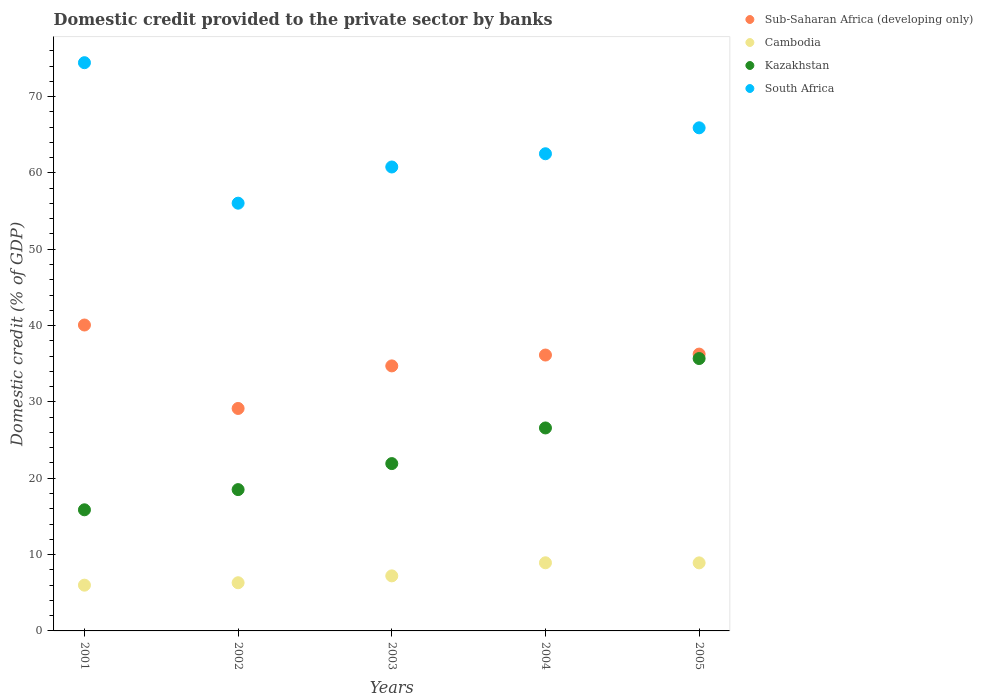Is the number of dotlines equal to the number of legend labels?
Keep it short and to the point. Yes. What is the domestic credit provided to the private sector by banks in Kazakhstan in 2004?
Make the answer very short. 26.59. Across all years, what is the maximum domestic credit provided to the private sector by banks in Kazakhstan?
Provide a succinct answer. 35.68. Across all years, what is the minimum domestic credit provided to the private sector by banks in Kazakhstan?
Offer a very short reply. 15.87. In which year was the domestic credit provided to the private sector by banks in South Africa maximum?
Provide a succinct answer. 2001. What is the total domestic credit provided to the private sector by banks in Cambodia in the graph?
Provide a succinct answer. 37.36. What is the difference between the domestic credit provided to the private sector by banks in Sub-Saharan Africa (developing only) in 2003 and that in 2004?
Keep it short and to the point. -1.42. What is the difference between the domestic credit provided to the private sector by banks in Kazakhstan in 2002 and the domestic credit provided to the private sector by banks in Cambodia in 2001?
Offer a terse response. 12.52. What is the average domestic credit provided to the private sector by banks in South Africa per year?
Give a very brief answer. 63.93. In the year 2005, what is the difference between the domestic credit provided to the private sector by banks in Kazakhstan and domestic credit provided to the private sector by banks in Sub-Saharan Africa (developing only)?
Offer a terse response. -0.58. What is the ratio of the domestic credit provided to the private sector by banks in South Africa in 2003 to that in 2005?
Your response must be concise. 0.92. Is the difference between the domestic credit provided to the private sector by banks in Kazakhstan in 2003 and 2004 greater than the difference between the domestic credit provided to the private sector by banks in Sub-Saharan Africa (developing only) in 2003 and 2004?
Offer a terse response. No. What is the difference between the highest and the second highest domestic credit provided to the private sector by banks in South Africa?
Offer a very short reply. 8.53. What is the difference between the highest and the lowest domestic credit provided to the private sector by banks in Sub-Saharan Africa (developing only)?
Give a very brief answer. 10.93. In how many years, is the domestic credit provided to the private sector by banks in Kazakhstan greater than the average domestic credit provided to the private sector by banks in Kazakhstan taken over all years?
Offer a terse response. 2. Is it the case that in every year, the sum of the domestic credit provided to the private sector by banks in South Africa and domestic credit provided to the private sector by banks in Sub-Saharan Africa (developing only)  is greater than the sum of domestic credit provided to the private sector by banks in Kazakhstan and domestic credit provided to the private sector by banks in Cambodia?
Your answer should be very brief. Yes. Is it the case that in every year, the sum of the domestic credit provided to the private sector by banks in South Africa and domestic credit provided to the private sector by banks in Kazakhstan  is greater than the domestic credit provided to the private sector by banks in Sub-Saharan Africa (developing only)?
Your answer should be very brief. Yes. Is the domestic credit provided to the private sector by banks in Kazakhstan strictly greater than the domestic credit provided to the private sector by banks in Cambodia over the years?
Make the answer very short. Yes. How many years are there in the graph?
Make the answer very short. 5. What is the difference between two consecutive major ticks on the Y-axis?
Your response must be concise. 10. Does the graph contain any zero values?
Ensure brevity in your answer.  No. Does the graph contain grids?
Provide a short and direct response. No. Where does the legend appear in the graph?
Give a very brief answer. Top right. How many legend labels are there?
Give a very brief answer. 4. How are the legend labels stacked?
Provide a short and direct response. Vertical. What is the title of the graph?
Your answer should be very brief. Domestic credit provided to the private sector by banks. What is the label or title of the X-axis?
Ensure brevity in your answer.  Years. What is the label or title of the Y-axis?
Give a very brief answer. Domestic credit (% of GDP). What is the Domestic credit (% of GDP) in Sub-Saharan Africa (developing only) in 2001?
Your response must be concise. 40.07. What is the Domestic credit (% of GDP) of Cambodia in 2001?
Provide a succinct answer. 5.99. What is the Domestic credit (% of GDP) of Kazakhstan in 2001?
Provide a short and direct response. 15.87. What is the Domestic credit (% of GDP) of South Africa in 2001?
Keep it short and to the point. 74.43. What is the Domestic credit (% of GDP) of Sub-Saharan Africa (developing only) in 2002?
Keep it short and to the point. 29.14. What is the Domestic credit (% of GDP) in Cambodia in 2002?
Keep it short and to the point. 6.31. What is the Domestic credit (% of GDP) in Kazakhstan in 2002?
Your answer should be very brief. 18.51. What is the Domestic credit (% of GDP) in South Africa in 2002?
Ensure brevity in your answer.  56.03. What is the Domestic credit (% of GDP) in Sub-Saharan Africa (developing only) in 2003?
Ensure brevity in your answer.  34.72. What is the Domestic credit (% of GDP) in Cambodia in 2003?
Ensure brevity in your answer.  7.21. What is the Domestic credit (% of GDP) in Kazakhstan in 2003?
Keep it short and to the point. 21.92. What is the Domestic credit (% of GDP) of South Africa in 2003?
Ensure brevity in your answer.  60.77. What is the Domestic credit (% of GDP) in Sub-Saharan Africa (developing only) in 2004?
Your answer should be very brief. 36.14. What is the Domestic credit (% of GDP) in Cambodia in 2004?
Give a very brief answer. 8.92. What is the Domestic credit (% of GDP) of Kazakhstan in 2004?
Your answer should be compact. 26.59. What is the Domestic credit (% of GDP) in South Africa in 2004?
Offer a terse response. 62.5. What is the Domestic credit (% of GDP) of Sub-Saharan Africa (developing only) in 2005?
Make the answer very short. 36.26. What is the Domestic credit (% of GDP) in Cambodia in 2005?
Provide a short and direct response. 8.92. What is the Domestic credit (% of GDP) of Kazakhstan in 2005?
Your answer should be compact. 35.68. What is the Domestic credit (% of GDP) of South Africa in 2005?
Your response must be concise. 65.9. Across all years, what is the maximum Domestic credit (% of GDP) of Sub-Saharan Africa (developing only)?
Give a very brief answer. 40.07. Across all years, what is the maximum Domestic credit (% of GDP) in Cambodia?
Your answer should be compact. 8.92. Across all years, what is the maximum Domestic credit (% of GDP) in Kazakhstan?
Keep it short and to the point. 35.68. Across all years, what is the maximum Domestic credit (% of GDP) in South Africa?
Your answer should be compact. 74.43. Across all years, what is the minimum Domestic credit (% of GDP) of Sub-Saharan Africa (developing only)?
Make the answer very short. 29.14. Across all years, what is the minimum Domestic credit (% of GDP) of Cambodia?
Your answer should be very brief. 5.99. Across all years, what is the minimum Domestic credit (% of GDP) in Kazakhstan?
Offer a very short reply. 15.87. Across all years, what is the minimum Domestic credit (% of GDP) in South Africa?
Your answer should be compact. 56.03. What is the total Domestic credit (% of GDP) of Sub-Saharan Africa (developing only) in the graph?
Keep it short and to the point. 176.33. What is the total Domestic credit (% of GDP) in Cambodia in the graph?
Provide a succinct answer. 37.36. What is the total Domestic credit (% of GDP) in Kazakhstan in the graph?
Offer a terse response. 118.56. What is the total Domestic credit (% of GDP) in South Africa in the graph?
Make the answer very short. 319.64. What is the difference between the Domestic credit (% of GDP) in Sub-Saharan Africa (developing only) in 2001 and that in 2002?
Your answer should be very brief. 10.93. What is the difference between the Domestic credit (% of GDP) in Cambodia in 2001 and that in 2002?
Offer a terse response. -0.32. What is the difference between the Domestic credit (% of GDP) of Kazakhstan in 2001 and that in 2002?
Provide a short and direct response. -2.65. What is the difference between the Domestic credit (% of GDP) of South Africa in 2001 and that in 2002?
Offer a terse response. 18.4. What is the difference between the Domestic credit (% of GDP) in Sub-Saharan Africa (developing only) in 2001 and that in 2003?
Your answer should be very brief. 5.36. What is the difference between the Domestic credit (% of GDP) in Cambodia in 2001 and that in 2003?
Your answer should be compact. -1.22. What is the difference between the Domestic credit (% of GDP) in Kazakhstan in 2001 and that in 2003?
Provide a succinct answer. -6.05. What is the difference between the Domestic credit (% of GDP) in South Africa in 2001 and that in 2003?
Give a very brief answer. 13.66. What is the difference between the Domestic credit (% of GDP) in Sub-Saharan Africa (developing only) in 2001 and that in 2004?
Provide a succinct answer. 3.93. What is the difference between the Domestic credit (% of GDP) of Cambodia in 2001 and that in 2004?
Offer a terse response. -2.93. What is the difference between the Domestic credit (% of GDP) in Kazakhstan in 2001 and that in 2004?
Offer a very short reply. -10.72. What is the difference between the Domestic credit (% of GDP) of South Africa in 2001 and that in 2004?
Your response must be concise. 11.93. What is the difference between the Domestic credit (% of GDP) in Sub-Saharan Africa (developing only) in 2001 and that in 2005?
Keep it short and to the point. 3.81. What is the difference between the Domestic credit (% of GDP) in Cambodia in 2001 and that in 2005?
Provide a succinct answer. -2.92. What is the difference between the Domestic credit (% of GDP) in Kazakhstan in 2001 and that in 2005?
Your response must be concise. -19.81. What is the difference between the Domestic credit (% of GDP) of South Africa in 2001 and that in 2005?
Keep it short and to the point. 8.53. What is the difference between the Domestic credit (% of GDP) in Sub-Saharan Africa (developing only) in 2002 and that in 2003?
Make the answer very short. -5.57. What is the difference between the Domestic credit (% of GDP) in Cambodia in 2002 and that in 2003?
Your answer should be compact. -0.9. What is the difference between the Domestic credit (% of GDP) of Kazakhstan in 2002 and that in 2003?
Your response must be concise. -3.41. What is the difference between the Domestic credit (% of GDP) of South Africa in 2002 and that in 2003?
Provide a short and direct response. -4.74. What is the difference between the Domestic credit (% of GDP) of Sub-Saharan Africa (developing only) in 2002 and that in 2004?
Keep it short and to the point. -7. What is the difference between the Domestic credit (% of GDP) of Cambodia in 2002 and that in 2004?
Provide a short and direct response. -2.61. What is the difference between the Domestic credit (% of GDP) of Kazakhstan in 2002 and that in 2004?
Offer a terse response. -8.08. What is the difference between the Domestic credit (% of GDP) of South Africa in 2002 and that in 2004?
Give a very brief answer. -6.47. What is the difference between the Domestic credit (% of GDP) in Sub-Saharan Africa (developing only) in 2002 and that in 2005?
Offer a terse response. -7.12. What is the difference between the Domestic credit (% of GDP) of Cambodia in 2002 and that in 2005?
Provide a short and direct response. -2.6. What is the difference between the Domestic credit (% of GDP) in Kazakhstan in 2002 and that in 2005?
Your answer should be very brief. -17.17. What is the difference between the Domestic credit (% of GDP) of South Africa in 2002 and that in 2005?
Offer a very short reply. -9.87. What is the difference between the Domestic credit (% of GDP) in Sub-Saharan Africa (developing only) in 2003 and that in 2004?
Your answer should be compact. -1.42. What is the difference between the Domestic credit (% of GDP) in Cambodia in 2003 and that in 2004?
Make the answer very short. -1.71. What is the difference between the Domestic credit (% of GDP) of Kazakhstan in 2003 and that in 2004?
Offer a very short reply. -4.67. What is the difference between the Domestic credit (% of GDP) in South Africa in 2003 and that in 2004?
Offer a terse response. -1.73. What is the difference between the Domestic credit (% of GDP) of Sub-Saharan Africa (developing only) in 2003 and that in 2005?
Keep it short and to the point. -1.55. What is the difference between the Domestic credit (% of GDP) of Cambodia in 2003 and that in 2005?
Provide a succinct answer. -1.7. What is the difference between the Domestic credit (% of GDP) in Kazakhstan in 2003 and that in 2005?
Offer a very short reply. -13.76. What is the difference between the Domestic credit (% of GDP) of South Africa in 2003 and that in 2005?
Make the answer very short. -5.13. What is the difference between the Domestic credit (% of GDP) in Sub-Saharan Africa (developing only) in 2004 and that in 2005?
Your answer should be very brief. -0.12. What is the difference between the Domestic credit (% of GDP) in Cambodia in 2004 and that in 2005?
Provide a short and direct response. 0.01. What is the difference between the Domestic credit (% of GDP) in Kazakhstan in 2004 and that in 2005?
Provide a succinct answer. -9.09. What is the difference between the Domestic credit (% of GDP) in South Africa in 2004 and that in 2005?
Provide a succinct answer. -3.4. What is the difference between the Domestic credit (% of GDP) of Sub-Saharan Africa (developing only) in 2001 and the Domestic credit (% of GDP) of Cambodia in 2002?
Provide a succinct answer. 33.76. What is the difference between the Domestic credit (% of GDP) of Sub-Saharan Africa (developing only) in 2001 and the Domestic credit (% of GDP) of Kazakhstan in 2002?
Offer a terse response. 21.56. What is the difference between the Domestic credit (% of GDP) of Sub-Saharan Africa (developing only) in 2001 and the Domestic credit (% of GDP) of South Africa in 2002?
Provide a short and direct response. -15.96. What is the difference between the Domestic credit (% of GDP) of Cambodia in 2001 and the Domestic credit (% of GDP) of Kazakhstan in 2002?
Provide a succinct answer. -12.52. What is the difference between the Domestic credit (% of GDP) in Cambodia in 2001 and the Domestic credit (% of GDP) in South Africa in 2002?
Give a very brief answer. -50.04. What is the difference between the Domestic credit (% of GDP) in Kazakhstan in 2001 and the Domestic credit (% of GDP) in South Africa in 2002?
Your answer should be very brief. -40.16. What is the difference between the Domestic credit (% of GDP) in Sub-Saharan Africa (developing only) in 2001 and the Domestic credit (% of GDP) in Cambodia in 2003?
Offer a terse response. 32.86. What is the difference between the Domestic credit (% of GDP) of Sub-Saharan Africa (developing only) in 2001 and the Domestic credit (% of GDP) of Kazakhstan in 2003?
Your response must be concise. 18.15. What is the difference between the Domestic credit (% of GDP) of Sub-Saharan Africa (developing only) in 2001 and the Domestic credit (% of GDP) of South Africa in 2003?
Make the answer very short. -20.7. What is the difference between the Domestic credit (% of GDP) in Cambodia in 2001 and the Domestic credit (% of GDP) in Kazakhstan in 2003?
Provide a short and direct response. -15.92. What is the difference between the Domestic credit (% of GDP) in Cambodia in 2001 and the Domestic credit (% of GDP) in South Africa in 2003?
Offer a terse response. -54.78. What is the difference between the Domestic credit (% of GDP) of Kazakhstan in 2001 and the Domestic credit (% of GDP) of South Africa in 2003?
Provide a succinct answer. -44.91. What is the difference between the Domestic credit (% of GDP) in Sub-Saharan Africa (developing only) in 2001 and the Domestic credit (% of GDP) in Cambodia in 2004?
Your response must be concise. 31.15. What is the difference between the Domestic credit (% of GDP) in Sub-Saharan Africa (developing only) in 2001 and the Domestic credit (% of GDP) in Kazakhstan in 2004?
Keep it short and to the point. 13.48. What is the difference between the Domestic credit (% of GDP) in Sub-Saharan Africa (developing only) in 2001 and the Domestic credit (% of GDP) in South Africa in 2004?
Your response must be concise. -22.43. What is the difference between the Domestic credit (% of GDP) in Cambodia in 2001 and the Domestic credit (% of GDP) in Kazakhstan in 2004?
Ensure brevity in your answer.  -20.59. What is the difference between the Domestic credit (% of GDP) of Cambodia in 2001 and the Domestic credit (% of GDP) of South Africa in 2004?
Give a very brief answer. -56.51. What is the difference between the Domestic credit (% of GDP) of Kazakhstan in 2001 and the Domestic credit (% of GDP) of South Africa in 2004?
Provide a short and direct response. -46.64. What is the difference between the Domestic credit (% of GDP) in Sub-Saharan Africa (developing only) in 2001 and the Domestic credit (% of GDP) in Cambodia in 2005?
Your answer should be compact. 31.16. What is the difference between the Domestic credit (% of GDP) of Sub-Saharan Africa (developing only) in 2001 and the Domestic credit (% of GDP) of Kazakhstan in 2005?
Your answer should be compact. 4.39. What is the difference between the Domestic credit (% of GDP) in Sub-Saharan Africa (developing only) in 2001 and the Domestic credit (% of GDP) in South Africa in 2005?
Your answer should be compact. -25.83. What is the difference between the Domestic credit (% of GDP) of Cambodia in 2001 and the Domestic credit (% of GDP) of Kazakhstan in 2005?
Make the answer very short. -29.69. What is the difference between the Domestic credit (% of GDP) in Cambodia in 2001 and the Domestic credit (% of GDP) in South Africa in 2005?
Offer a terse response. -59.91. What is the difference between the Domestic credit (% of GDP) of Kazakhstan in 2001 and the Domestic credit (% of GDP) of South Africa in 2005?
Make the answer very short. -50.04. What is the difference between the Domestic credit (% of GDP) in Sub-Saharan Africa (developing only) in 2002 and the Domestic credit (% of GDP) in Cambodia in 2003?
Your response must be concise. 21.93. What is the difference between the Domestic credit (% of GDP) of Sub-Saharan Africa (developing only) in 2002 and the Domestic credit (% of GDP) of Kazakhstan in 2003?
Your answer should be very brief. 7.22. What is the difference between the Domestic credit (% of GDP) in Sub-Saharan Africa (developing only) in 2002 and the Domestic credit (% of GDP) in South Africa in 2003?
Make the answer very short. -31.63. What is the difference between the Domestic credit (% of GDP) in Cambodia in 2002 and the Domestic credit (% of GDP) in Kazakhstan in 2003?
Offer a terse response. -15.61. What is the difference between the Domestic credit (% of GDP) in Cambodia in 2002 and the Domestic credit (% of GDP) in South Africa in 2003?
Keep it short and to the point. -54.46. What is the difference between the Domestic credit (% of GDP) in Kazakhstan in 2002 and the Domestic credit (% of GDP) in South Africa in 2003?
Your answer should be compact. -42.26. What is the difference between the Domestic credit (% of GDP) in Sub-Saharan Africa (developing only) in 2002 and the Domestic credit (% of GDP) in Cambodia in 2004?
Your answer should be very brief. 20.22. What is the difference between the Domestic credit (% of GDP) of Sub-Saharan Africa (developing only) in 2002 and the Domestic credit (% of GDP) of Kazakhstan in 2004?
Make the answer very short. 2.55. What is the difference between the Domestic credit (% of GDP) of Sub-Saharan Africa (developing only) in 2002 and the Domestic credit (% of GDP) of South Africa in 2004?
Provide a short and direct response. -33.36. What is the difference between the Domestic credit (% of GDP) in Cambodia in 2002 and the Domestic credit (% of GDP) in Kazakhstan in 2004?
Make the answer very short. -20.28. What is the difference between the Domestic credit (% of GDP) in Cambodia in 2002 and the Domestic credit (% of GDP) in South Africa in 2004?
Offer a very short reply. -56.19. What is the difference between the Domestic credit (% of GDP) in Kazakhstan in 2002 and the Domestic credit (% of GDP) in South Africa in 2004?
Make the answer very short. -43.99. What is the difference between the Domestic credit (% of GDP) in Sub-Saharan Africa (developing only) in 2002 and the Domestic credit (% of GDP) in Cambodia in 2005?
Provide a short and direct response. 20.23. What is the difference between the Domestic credit (% of GDP) in Sub-Saharan Africa (developing only) in 2002 and the Domestic credit (% of GDP) in Kazakhstan in 2005?
Offer a terse response. -6.54. What is the difference between the Domestic credit (% of GDP) in Sub-Saharan Africa (developing only) in 2002 and the Domestic credit (% of GDP) in South Africa in 2005?
Keep it short and to the point. -36.76. What is the difference between the Domestic credit (% of GDP) in Cambodia in 2002 and the Domestic credit (% of GDP) in Kazakhstan in 2005?
Make the answer very short. -29.37. What is the difference between the Domestic credit (% of GDP) in Cambodia in 2002 and the Domestic credit (% of GDP) in South Africa in 2005?
Your answer should be very brief. -59.59. What is the difference between the Domestic credit (% of GDP) of Kazakhstan in 2002 and the Domestic credit (% of GDP) of South Africa in 2005?
Offer a very short reply. -47.39. What is the difference between the Domestic credit (% of GDP) in Sub-Saharan Africa (developing only) in 2003 and the Domestic credit (% of GDP) in Cambodia in 2004?
Give a very brief answer. 25.79. What is the difference between the Domestic credit (% of GDP) of Sub-Saharan Africa (developing only) in 2003 and the Domestic credit (% of GDP) of Kazakhstan in 2004?
Offer a terse response. 8.13. What is the difference between the Domestic credit (% of GDP) in Sub-Saharan Africa (developing only) in 2003 and the Domestic credit (% of GDP) in South Africa in 2004?
Provide a short and direct response. -27.79. What is the difference between the Domestic credit (% of GDP) of Cambodia in 2003 and the Domestic credit (% of GDP) of Kazakhstan in 2004?
Your response must be concise. -19.38. What is the difference between the Domestic credit (% of GDP) in Cambodia in 2003 and the Domestic credit (% of GDP) in South Africa in 2004?
Your answer should be compact. -55.29. What is the difference between the Domestic credit (% of GDP) of Kazakhstan in 2003 and the Domestic credit (% of GDP) of South Africa in 2004?
Offer a terse response. -40.59. What is the difference between the Domestic credit (% of GDP) in Sub-Saharan Africa (developing only) in 2003 and the Domestic credit (% of GDP) in Cambodia in 2005?
Offer a terse response. 25.8. What is the difference between the Domestic credit (% of GDP) of Sub-Saharan Africa (developing only) in 2003 and the Domestic credit (% of GDP) of Kazakhstan in 2005?
Your answer should be compact. -0.96. What is the difference between the Domestic credit (% of GDP) of Sub-Saharan Africa (developing only) in 2003 and the Domestic credit (% of GDP) of South Africa in 2005?
Provide a succinct answer. -31.19. What is the difference between the Domestic credit (% of GDP) of Cambodia in 2003 and the Domestic credit (% of GDP) of Kazakhstan in 2005?
Give a very brief answer. -28.47. What is the difference between the Domestic credit (% of GDP) in Cambodia in 2003 and the Domestic credit (% of GDP) in South Africa in 2005?
Provide a short and direct response. -58.69. What is the difference between the Domestic credit (% of GDP) in Kazakhstan in 2003 and the Domestic credit (% of GDP) in South Africa in 2005?
Provide a succinct answer. -43.98. What is the difference between the Domestic credit (% of GDP) in Sub-Saharan Africa (developing only) in 2004 and the Domestic credit (% of GDP) in Cambodia in 2005?
Your answer should be very brief. 27.22. What is the difference between the Domestic credit (% of GDP) of Sub-Saharan Africa (developing only) in 2004 and the Domestic credit (% of GDP) of Kazakhstan in 2005?
Keep it short and to the point. 0.46. What is the difference between the Domestic credit (% of GDP) of Sub-Saharan Africa (developing only) in 2004 and the Domestic credit (% of GDP) of South Africa in 2005?
Your answer should be very brief. -29.76. What is the difference between the Domestic credit (% of GDP) of Cambodia in 2004 and the Domestic credit (% of GDP) of Kazakhstan in 2005?
Offer a terse response. -26.75. What is the difference between the Domestic credit (% of GDP) in Cambodia in 2004 and the Domestic credit (% of GDP) in South Africa in 2005?
Keep it short and to the point. -56.98. What is the difference between the Domestic credit (% of GDP) of Kazakhstan in 2004 and the Domestic credit (% of GDP) of South Africa in 2005?
Keep it short and to the point. -39.31. What is the average Domestic credit (% of GDP) in Sub-Saharan Africa (developing only) per year?
Provide a succinct answer. 35.27. What is the average Domestic credit (% of GDP) of Cambodia per year?
Give a very brief answer. 7.47. What is the average Domestic credit (% of GDP) of Kazakhstan per year?
Your answer should be very brief. 23.71. What is the average Domestic credit (% of GDP) of South Africa per year?
Keep it short and to the point. 63.93. In the year 2001, what is the difference between the Domestic credit (% of GDP) of Sub-Saharan Africa (developing only) and Domestic credit (% of GDP) of Cambodia?
Offer a very short reply. 34.08. In the year 2001, what is the difference between the Domestic credit (% of GDP) of Sub-Saharan Africa (developing only) and Domestic credit (% of GDP) of Kazakhstan?
Offer a terse response. 24.21. In the year 2001, what is the difference between the Domestic credit (% of GDP) in Sub-Saharan Africa (developing only) and Domestic credit (% of GDP) in South Africa?
Make the answer very short. -34.36. In the year 2001, what is the difference between the Domestic credit (% of GDP) of Cambodia and Domestic credit (% of GDP) of Kazakhstan?
Your answer should be very brief. -9.87. In the year 2001, what is the difference between the Domestic credit (% of GDP) in Cambodia and Domestic credit (% of GDP) in South Africa?
Keep it short and to the point. -68.44. In the year 2001, what is the difference between the Domestic credit (% of GDP) of Kazakhstan and Domestic credit (% of GDP) of South Africa?
Ensure brevity in your answer.  -58.57. In the year 2002, what is the difference between the Domestic credit (% of GDP) of Sub-Saharan Africa (developing only) and Domestic credit (% of GDP) of Cambodia?
Your answer should be very brief. 22.83. In the year 2002, what is the difference between the Domestic credit (% of GDP) in Sub-Saharan Africa (developing only) and Domestic credit (% of GDP) in Kazakhstan?
Provide a short and direct response. 10.63. In the year 2002, what is the difference between the Domestic credit (% of GDP) of Sub-Saharan Africa (developing only) and Domestic credit (% of GDP) of South Africa?
Give a very brief answer. -26.89. In the year 2002, what is the difference between the Domestic credit (% of GDP) of Cambodia and Domestic credit (% of GDP) of Kazakhstan?
Your answer should be compact. -12.2. In the year 2002, what is the difference between the Domestic credit (% of GDP) in Cambodia and Domestic credit (% of GDP) in South Africa?
Offer a terse response. -49.72. In the year 2002, what is the difference between the Domestic credit (% of GDP) in Kazakhstan and Domestic credit (% of GDP) in South Africa?
Give a very brief answer. -37.52. In the year 2003, what is the difference between the Domestic credit (% of GDP) in Sub-Saharan Africa (developing only) and Domestic credit (% of GDP) in Cambodia?
Offer a very short reply. 27.5. In the year 2003, what is the difference between the Domestic credit (% of GDP) in Sub-Saharan Africa (developing only) and Domestic credit (% of GDP) in Kazakhstan?
Provide a short and direct response. 12.8. In the year 2003, what is the difference between the Domestic credit (% of GDP) of Sub-Saharan Africa (developing only) and Domestic credit (% of GDP) of South Africa?
Your answer should be very brief. -26.06. In the year 2003, what is the difference between the Domestic credit (% of GDP) of Cambodia and Domestic credit (% of GDP) of Kazakhstan?
Provide a succinct answer. -14.71. In the year 2003, what is the difference between the Domestic credit (% of GDP) in Cambodia and Domestic credit (% of GDP) in South Africa?
Make the answer very short. -53.56. In the year 2003, what is the difference between the Domestic credit (% of GDP) of Kazakhstan and Domestic credit (% of GDP) of South Africa?
Keep it short and to the point. -38.85. In the year 2004, what is the difference between the Domestic credit (% of GDP) of Sub-Saharan Africa (developing only) and Domestic credit (% of GDP) of Cambodia?
Provide a succinct answer. 27.21. In the year 2004, what is the difference between the Domestic credit (% of GDP) in Sub-Saharan Africa (developing only) and Domestic credit (% of GDP) in Kazakhstan?
Your answer should be compact. 9.55. In the year 2004, what is the difference between the Domestic credit (% of GDP) of Sub-Saharan Africa (developing only) and Domestic credit (% of GDP) of South Africa?
Your answer should be compact. -26.37. In the year 2004, what is the difference between the Domestic credit (% of GDP) of Cambodia and Domestic credit (% of GDP) of Kazakhstan?
Give a very brief answer. -17.66. In the year 2004, what is the difference between the Domestic credit (% of GDP) of Cambodia and Domestic credit (% of GDP) of South Africa?
Ensure brevity in your answer.  -53.58. In the year 2004, what is the difference between the Domestic credit (% of GDP) in Kazakhstan and Domestic credit (% of GDP) in South Africa?
Ensure brevity in your answer.  -35.92. In the year 2005, what is the difference between the Domestic credit (% of GDP) in Sub-Saharan Africa (developing only) and Domestic credit (% of GDP) in Cambodia?
Offer a terse response. 27.35. In the year 2005, what is the difference between the Domestic credit (% of GDP) in Sub-Saharan Africa (developing only) and Domestic credit (% of GDP) in Kazakhstan?
Your response must be concise. 0.58. In the year 2005, what is the difference between the Domestic credit (% of GDP) in Sub-Saharan Africa (developing only) and Domestic credit (% of GDP) in South Africa?
Give a very brief answer. -29.64. In the year 2005, what is the difference between the Domestic credit (% of GDP) in Cambodia and Domestic credit (% of GDP) in Kazakhstan?
Provide a short and direct response. -26.76. In the year 2005, what is the difference between the Domestic credit (% of GDP) of Cambodia and Domestic credit (% of GDP) of South Africa?
Ensure brevity in your answer.  -56.99. In the year 2005, what is the difference between the Domestic credit (% of GDP) of Kazakhstan and Domestic credit (% of GDP) of South Africa?
Keep it short and to the point. -30.22. What is the ratio of the Domestic credit (% of GDP) in Sub-Saharan Africa (developing only) in 2001 to that in 2002?
Offer a terse response. 1.38. What is the ratio of the Domestic credit (% of GDP) in Cambodia in 2001 to that in 2002?
Make the answer very short. 0.95. What is the ratio of the Domestic credit (% of GDP) of South Africa in 2001 to that in 2002?
Your answer should be compact. 1.33. What is the ratio of the Domestic credit (% of GDP) in Sub-Saharan Africa (developing only) in 2001 to that in 2003?
Offer a terse response. 1.15. What is the ratio of the Domestic credit (% of GDP) of Cambodia in 2001 to that in 2003?
Your answer should be compact. 0.83. What is the ratio of the Domestic credit (% of GDP) in Kazakhstan in 2001 to that in 2003?
Keep it short and to the point. 0.72. What is the ratio of the Domestic credit (% of GDP) in South Africa in 2001 to that in 2003?
Make the answer very short. 1.22. What is the ratio of the Domestic credit (% of GDP) in Sub-Saharan Africa (developing only) in 2001 to that in 2004?
Give a very brief answer. 1.11. What is the ratio of the Domestic credit (% of GDP) in Cambodia in 2001 to that in 2004?
Provide a succinct answer. 0.67. What is the ratio of the Domestic credit (% of GDP) of Kazakhstan in 2001 to that in 2004?
Your answer should be very brief. 0.6. What is the ratio of the Domestic credit (% of GDP) of South Africa in 2001 to that in 2004?
Give a very brief answer. 1.19. What is the ratio of the Domestic credit (% of GDP) of Sub-Saharan Africa (developing only) in 2001 to that in 2005?
Make the answer very short. 1.1. What is the ratio of the Domestic credit (% of GDP) of Cambodia in 2001 to that in 2005?
Provide a short and direct response. 0.67. What is the ratio of the Domestic credit (% of GDP) of Kazakhstan in 2001 to that in 2005?
Ensure brevity in your answer.  0.44. What is the ratio of the Domestic credit (% of GDP) of South Africa in 2001 to that in 2005?
Ensure brevity in your answer.  1.13. What is the ratio of the Domestic credit (% of GDP) of Sub-Saharan Africa (developing only) in 2002 to that in 2003?
Provide a succinct answer. 0.84. What is the ratio of the Domestic credit (% of GDP) in Cambodia in 2002 to that in 2003?
Your answer should be compact. 0.88. What is the ratio of the Domestic credit (% of GDP) in Kazakhstan in 2002 to that in 2003?
Give a very brief answer. 0.84. What is the ratio of the Domestic credit (% of GDP) of South Africa in 2002 to that in 2003?
Offer a very short reply. 0.92. What is the ratio of the Domestic credit (% of GDP) of Sub-Saharan Africa (developing only) in 2002 to that in 2004?
Offer a terse response. 0.81. What is the ratio of the Domestic credit (% of GDP) of Cambodia in 2002 to that in 2004?
Your response must be concise. 0.71. What is the ratio of the Domestic credit (% of GDP) in Kazakhstan in 2002 to that in 2004?
Your response must be concise. 0.7. What is the ratio of the Domestic credit (% of GDP) in South Africa in 2002 to that in 2004?
Your answer should be very brief. 0.9. What is the ratio of the Domestic credit (% of GDP) of Sub-Saharan Africa (developing only) in 2002 to that in 2005?
Your answer should be very brief. 0.8. What is the ratio of the Domestic credit (% of GDP) of Cambodia in 2002 to that in 2005?
Your response must be concise. 0.71. What is the ratio of the Domestic credit (% of GDP) in Kazakhstan in 2002 to that in 2005?
Ensure brevity in your answer.  0.52. What is the ratio of the Domestic credit (% of GDP) of South Africa in 2002 to that in 2005?
Your answer should be very brief. 0.85. What is the ratio of the Domestic credit (% of GDP) in Sub-Saharan Africa (developing only) in 2003 to that in 2004?
Your answer should be very brief. 0.96. What is the ratio of the Domestic credit (% of GDP) of Cambodia in 2003 to that in 2004?
Provide a short and direct response. 0.81. What is the ratio of the Domestic credit (% of GDP) in Kazakhstan in 2003 to that in 2004?
Your answer should be very brief. 0.82. What is the ratio of the Domestic credit (% of GDP) in South Africa in 2003 to that in 2004?
Provide a short and direct response. 0.97. What is the ratio of the Domestic credit (% of GDP) in Sub-Saharan Africa (developing only) in 2003 to that in 2005?
Your answer should be very brief. 0.96. What is the ratio of the Domestic credit (% of GDP) of Cambodia in 2003 to that in 2005?
Your response must be concise. 0.81. What is the ratio of the Domestic credit (% of GDP) of Kazakhstan in 2003 to that in 2005?
Provide a succinct answer. 0.61. What is the ratio of the Domestic credit (% of GDP) of South Africa in 2003 to that in 2005?
Provide a short and direct response. 0.92. What is the ratio of the Domestic credit (% of GDP) of Kazakhstan in 2004 to that in 2005?
Provide a short and direct response. 0.75. What is the ratio of the Domestic credit (% of GDP) of South Africa in 2004 to that in 2005?
Your answer should be very brief. 0.95. What is the difference between the highest and the second highest Domestic credit (% of GDP) in Sub-Saharan Africa (developing only)?
Your answer should be very brief. 3.81. What is the difference between the highest and the second highest Domestic credit (% of GDP) in Cambodia?
Offer a terse response. 0.01. What is the difference between the highest and the second highest Domestic credit (% of GDP) in Kazakhstan?
Your answer should be compact. 9.09. What is the difference between the highest and the second highest Domestic credit (% of GDP) in South Africa?
Your answer should be compact. 8.53. What is the difference between the highest and the lowest Domestic credit (% of GDP) of Sub-Saharan Africa (developing only)?
Your answer should be very brief. 10.93. What is the difference between the highest and the lowest Domestic credit (% of GDP) of Cambodia?
Your response must be concise. 2.93. What is the difference between the highest and the lowest Domestic credit (% of GDP) in Kazakhstan?
Provide a short and direct response. 19.81. What is the difference between the highest and the lowest Domestic credit (% of GDP) of South Africa?
Your answer should be compact. 18.4. 